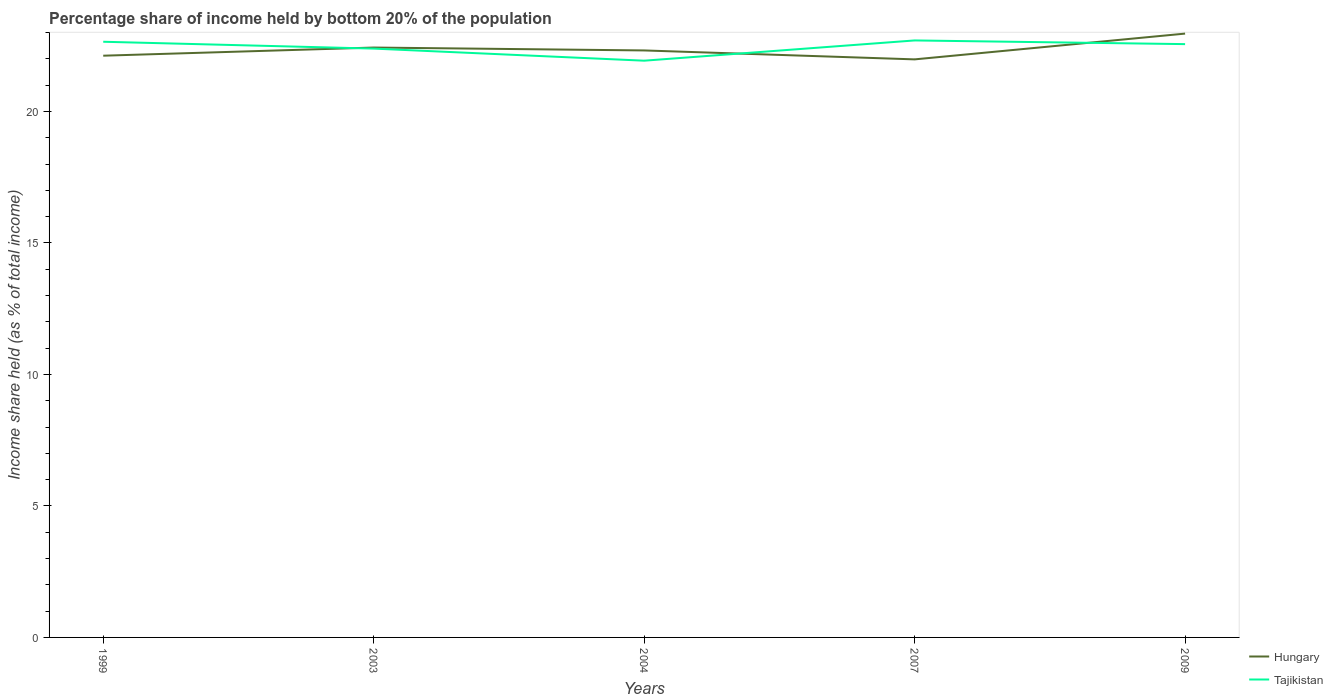Is the number of lines equal to the number of legend labels?
Offer a very short reply. Yes. Across all years, what is the maximum share of income held by bottom 20% of the population in Tajikistan?
Provide a succinct answer. 21.93. What is the total share of income held by bottom 20% of the population in Tajikistan in the graph?
Give a very brief answer. 0.14. What is the difference between the highest and the second highest share of income held by bottom 20% of the population in Hungary?
Provide a succinct answer. 0.98. What is the difference between the highest and the lowest share of income held by bottom 20% of the population in Tajikistan?
Your answer should be compact. 3. How many lines are there?
Offer a very short reply. 2. Where does the legend appear in the graph?
Provide a short and direct response. Bottom right. What is the title of the graph?
Give a very brief answer. Percentage share of income held by bottom 20% of the population. Does "Kosovo" appear as one of the legend labels in the graph?
Keep it short and to the point. No. What is the label or title of the Y-axis?
Give a very brief answer. Income share held (as % of total income). What is the Income share held (as % of total income) of Hungary in 1999?
Your answer should be compact. 22.12. What is the Income share held (as % of total income) in Tajikistan in 1999?
Make the answer very short. 22.65. What is the Income share held (as % of total income) of Hungary in 2003?
Keep it short and to the point. 22.43. What is the Income share held (as % of total income) in Tajikistan in 2003?
Ensure brevity in your answer.  22.39. What is the Income share held (as % of total income) in Hungary in 2004?
Your answer should be very brief. 22.32. What is the Income share held (as % of total income) of Tajikistan in 2004?
Offer a very short reply. 21.93. What is the Income share held (as % of total income) of Hungary in 2007?
Your answer should be very brief. 21.98. What is the Income share held (as % of total income) in Tajikistan in 2007?
Provide a short and direct response. 22.7. What is the Income share held (as % of total income) in Hungary in 2009?
Keep it short and to the point. 22.96. What is the Income share held (as % of total income) in Tajikistan in 2009?
Offer a terse response. 22.56. Across all years, what is the maximum Income share held (as % of total income) in Hungary?
Make the answer very short. 22.96. Across all years, what is the maximum Income share held (as % of total income) in Tajikistan?
Keep it short and to the point. 22.7. Across all years, what is the minimum Income share held (as % of total income) of Hungary?
Your answer should be very brief. 21.98. Across all years, what is the minimum Income share held (as % of total income) of Tajikistan?
Make the answer very short. 21.93. What is the total Income share held (as % of total income) of Hungary in the graph?
Make the answer very short. 111.81. What is the total Income share held (as % of total income) in Tajikistan in the graph?
Make the answer very short. 112.23. What is the difference between the Income share held (as % of total income) of Hungary in 1999 and that in 2003?
Keep it short and to the point. -0.31. What is the difference between the Income share held (as % of total income) of Tajikistan in 1999 and that in 2003?
Ensure brevity in your answer.  0.26. What is the difference between the Income share held (as % of total income) in Tajikistan in 1999 and that in 2004?
Offer a very short reply. 0.72. What is the difference between the Income share held (as % of total income) of Hungary in 1999 and that in 2007?
Provide a succinct answer. 0.14. What is the difference between the Income share held (as % of total income) in Tajikistan in 1999 and that in 2007?
Ensure brevity in your answer.  -0.05. What is the difference between the Income share held (as % of total income) in Hungary in 1999 and that in 2009?
Your answer should be compact. -0.84. What is the difference between the Income share held (as % of total income) of Tajikistan in 1999 and that in 2009?
Ensure brevity in your answer.  0.09. What is the difference between the Income share held (as % of total income) in Hungary in 2003 and that in 2004?
Your answer should be very brief. 0.11. What is the difference between the Income share held (as % of total income) of Tajikistan in 2003 and that in 2004?
Your answer should be very brief. 0.46. What is the difference between the Income share held (as % of total income) of Hungary in 2003 and that in 2007?
Ensure brevity in your answer.  0.45. What is the difference between the Income share held (as % of total income) in Tajikistan in 2003 and that in 2007?
Your answer should be compact. -0.31. What is the difference between the Income share held (as % of total income) in Hungary in 2003 and that in 2009?
Your answer should be compact. -0.53. What is the difference between the Income share held (as % of total income) in Tajikistan in 2003 and that in 2009?
Ensure brevity in your answer.  -0.17. What is the difference between the Income share held (as % of total income) in Hungary in 2004 and that in 2007?
Make the answer very short. 0.34. What is the difference between the Income share held (as % of total income) in Tajikistan in 2004 and that in 2007?
Provide a succinct answer. -0.77. What is the difference between the Income share held (as % of total income) of Hungary in 2004 and that in 2009?
Offer a terse response. -0.64. What is the difference between the Income share held (as % of total income) of Tajikistan in 2004 and that in 2009?
Your answer should be compact. -0.63. What is the difference between the Income share held (as % of total income) in Hungary in 2007 and that in 2009?
Your answer should be very brief. -0.98. What is the difference between the Income share held (as % of total income) in Tajikistan in 2007 and that in 2009?
Provide a succinct answer. 0.14. What is the difference between the Income share held (as % of total income) in Hungary in 1999 and the Income share held (as % of total income) in Tajikistan in 2003?
Offer a very short reply. -0.27. What is the difference between the Income share held (as % of total income) of Hungary in 1999 and the Income share held (as % of total income) of Tajikistan in 2004?
Offer a terse response. 0.19. What is the difference between the Income share held (as % of total income) of Hungary in 1999 and the Income share held (as % of total income) of Tajikistan in 2007?
Make the answer very short. -0.58. What is the difference between the Income share held (as % of total income) of Hungary in 1999 and the Income share held (as % of total income) of Tajikistan in 2009?
Your answer should be very brief. -0.44. What is the difference between the Income share held (as % of total income) in Hungary in 2003 and the Income share held (as % of total income) in Tajikistan in 2004?
Ensure brevity in your answer.  0.5. What is the difference between the Income share held (as % of total income) of Hungary in 2003 and the Income share held (as % of total income) of Tajikistan in 2007?
Make the answer very short. -0.27. What is the difference between the Income share held (as % of total income) in Hungary in 2003 and the Income share held (as % of total income) in Tajikistan in 2009?
Your answer should be very brief. -0.13. What is the difference between the Income share held (as % of total income) of Hungary in 2004 and the Income share held (as % of total income) of Tajikistan in 2007?
Give a very brief answer. -0.38. What is the difference between the Income share held (as % of total income) of Hungary in 2004 and the Income share held (as % of total income) of Tajikistan in 2009?
Provide a succinct answer. -0.24. What is the difference between the Income share held (as % of total income) in Hungary in 2007 and the Income share held (as % of total income) in Tajikistan in 2009?
Offer a terse response. -0.58. What is the average Income share held (as % of total income) of Hungary per year?
Give a very brief answer. 22.36. What is the average Income share held (as % of total income) in Tajikistan per year?
Ensure brevity in your answer.  22.45. In the year 1999, what is the difference between the Income share held (as % of total income) in Hungary and Income share held (as % of total income) in Tajikistan?
Offer a terse response. -0.53. In the year 2004, what is the difference between the Income share held (as % of total income) of Hungary and Income share held (as % of total income) of Tajikistan?
Keep it short and to the point. 0.39. In the year 2007, what is the difference between the Income share held (as % of total income) in Hungary and Income share held (as % of total income) in Tajikistan?
Your response must be concise. -0.72. In the year 2009, what is the difference between the Income share held (as % of total income) of Hungary and Income share held (as % of total income) of Tajikistan?
Make the answer very short. 0.4. What is the ratio of the Income share held (as % of total income) of Hungary in 1999 to that in 2003?
Your response must be concise. 0.99. What is the ratio of the Income share held (as % of total income) of Tajikistan in 1999 to that in 2003?
Provide a succinct answer. 1.01. What is the ratio of the Income share held (as % of total income) in Tajikistan in 1999 to that in 2004?
Your response must be concise. 1.03. What is the ratio of the Income share held (as % of total income) in Hungary in 1999 to that in 2007?
Offer a terse response. 1.01. What is the ratio of the Income share held (as % of total income) in Hungary in 1999 to that in 2009?
Provide a succinct answer. 0.96. What is the ratio of the Income share held (as % of total income) in Tajikistan in 1999 to that in 2009?
Give a very brief answer. 1. What is the ratio of the Income share held (as % of total income) of Hungary in 2003 to that in 2004?
Your response must be concise. 1. What is the ratio of the Income share held (as % of total income) of Tajikistan in 2003 to that in 2004?
Keep it short and to the point. 1.02. What is the ratio of the Income share held (as % of total income) in Hungary in 2003 to that in 2007?
Your answer should be compact. 1.02. What is the ratio of the Income share held (as % of total income) in Tajikistan in 2003 to that in 2007?
Give a very brief answer. 0.99. What is the ratio of the Income share held (as % of total income) in Hungary in 2003 to that in 2009?
Make the answer very short. 0.98. What is the ratio of the Income share held (as % of total income) of Hungary in 2004 to that in 2007?
Give a very brief answer. 1.02. What is the ratio of the Income share held (as % of total income) of Tajikistan in 2004 to that in 2007?
Offer a very short reply. 0.97. What is the ratio of the Income share held (as % of total income) of Hungary in 2004 to that in 2009?
Your response must be concise. 0.97. What is the ratio of the Income share held (as % of total income) of Tajikistan in 2004 to that in 2009?
Provide a succinct answer. 0.97. What is the ratio of the Income share held (as % of total income) in Hungary in 2007 to that in 2009?
Keep it short and to the point. 0.96. What is the ratio of the Income share held (as % of total income) in Tajikistan in 2007 to that in 2009?
Ensure brevity in your answer.  1.01. What is the difference between the highest and the second highest Income share held (as % of total income) of Hungary?
Offer a very short reply. 0.53. What is the difference between the highest and the lowest Income share held (as % of total income) in Hungary?
Your response must be concise. 0.98. What is the difference between the highest and the lowest Income share held (as % of total income) in Tajikistan?
Ensure brevity in your answer.  0.77. 